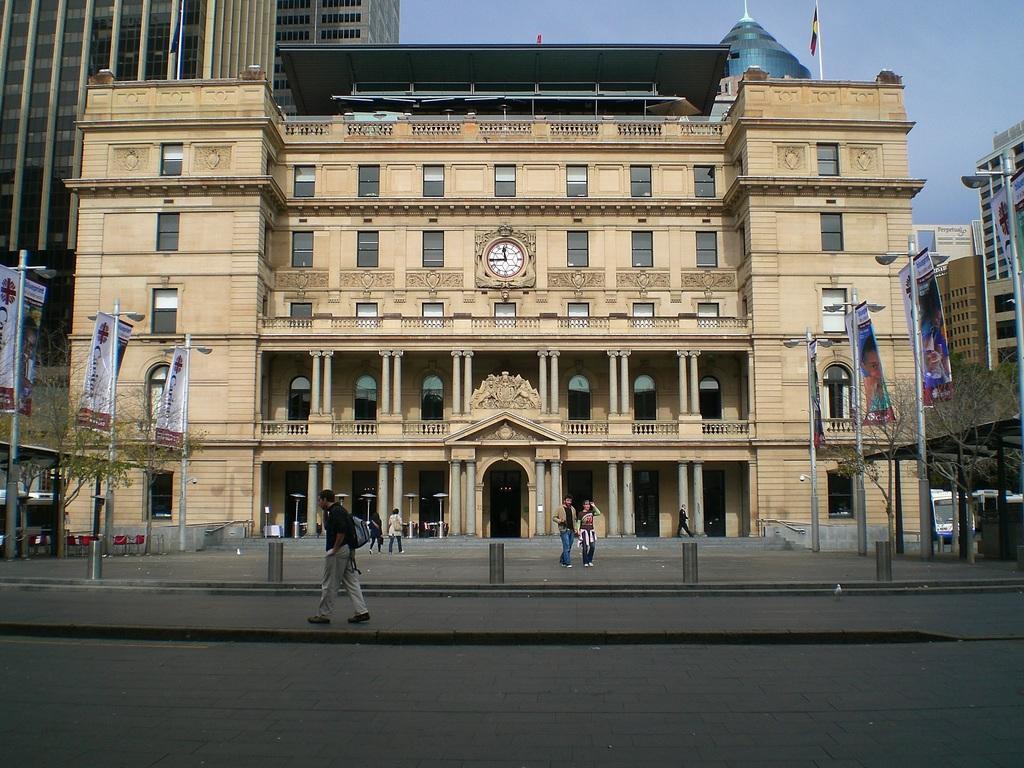In one or two sentences, can you explain what this image depicts? In the foreground of the picture we can see road, footpath and people. In the middle of the picture there are buildings, trees, flags, clock and other objects. At the top we can see sky. 